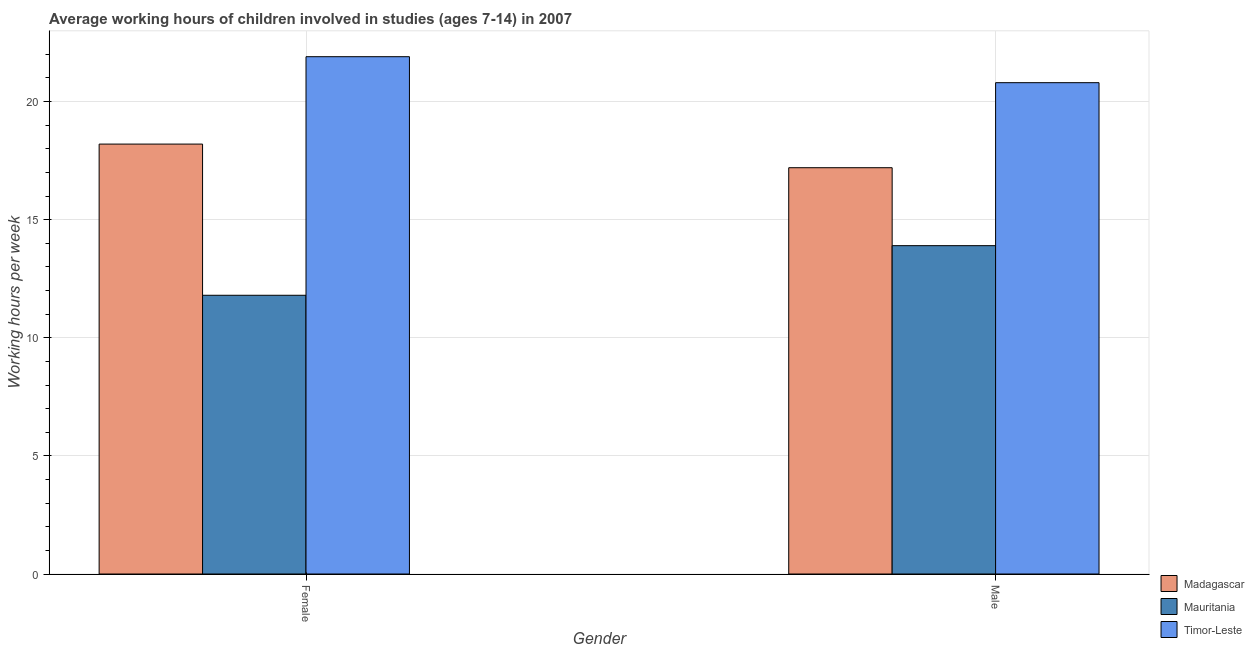How many different coloured bars are there?
Provide a short and direct response. 3. How many groups of bars are there?
Keep it short and to the point. 2. Are the number of bars on each tick of the X-axis equal?
Ensure brevity in your answer.  Yes. How many bars are there on the 2nd tick from the right?
Your answer should be compact. 3. What is the label of the 2nd group of bars from the left?
Your answer should be very brief. Male. What is the average working hour of female children in Mauritania?
Offer a terse response. 11.8. Across all countries, what is the maximum average working hour of female children?
Offer a very short reply. 21.9. Across all countries, what is the minimum average working hour of female children?
Give a very brief answer. 11.8. In which country was the average working hour of male children maximum?
Offer a very short reply. Timor-Leste. In which country was the average working hour of female children minimum?
Provide a succinct answer. Mauritania. What is the total average working hour of male children in the graph?
Keep it short and to the point. 51.9. What is the difference between the average working hour of male children in Mauritania and that in Madagascar?
Your answer should be compact. -3.3. What is the difference between the average working hour of female children in Madagascar and the average working hour of male children in Timor-Leste?
Your answer should be compact. -2.6. What is the average average working hour of female children per country?
Your answer should be compact. 17.3. What is the difference between the average working hour of female children and average working hour of male children in Timor-Leste?
Make the answer very short. 1.1. In how many countries, is the average working hour of female children greater than 7 hours?
Provide a short and direct response. 3. What is the ratio of the average working hour of female children in Madagascar to that in Mauritania?
Provide a short and direct response. 1.54. Is the average working hour of female children in Mauritania less than that in Madagascar?
Ensure brevity in your answer.  Yes. In how many countries, is the average working hour of female children greater than the average average working hour of female children taken over all countries?
Make the answer very short. 2. What does the 3rd bar from the left in Female represents?
Your answer should be very brief. Timor-Leste. What does the 2nd bar from the right in Female represents?
Provide a succinct answer. Mauritania. Are all the bars in the graph horizontal?
Your response must be concise. No. How many countries are there in the graph?
Ensure brevity in your answer.  3. Does the graph contain grids?
Provide a short and direct response. Yes. Where does the legend appear in the graph?
Your response must be concise. Bottom right. How are the legend labels stacked?
Your response must be concise. Vertical. What is the title of the graph?
Keep it short and to the point. Average working hours of children involved in studies (ages 7-14) in 2007. Does "Greenland" appear as one of the legend labels in the graph?
Offer a terse response. No. What is the label or title of the X-axis?
Offer a terse response. Gender. What is the label or title of the Y-axis?
Provide a succinct answer. Working hours per week. What is the Working hours per week in Madagascar in Female?
Your response must be concise. 18.2. What is the Working hours per week in Mauritania in Female?
Keep it short and to the point. 11.8. What is the Working hours per week of Timor-Leste in Female?
Your response must be concise. 21.9. What is the Working hours per week of Madagascar in Male?
Your response must be concise. 17.2. What is the Working hours per week of Timor-Leste in Male?
Provide a short and direct response. 20.8. Across all Gender, what is the maximum Working hours per week in Timor-Leste?
Provide a succinct answer. 21.9. Across all Gender, what is the minimum Working hours per week in Timor-Leste?
Provide a short and direct response. 20.8. What is the total Working hours per week of Madagascar in the graph?
Give a very brief answer. 35.4. What is the total Working hours per week in Mauritania in the graph?
Ensure brevity in your answer.  25.7. What is the total Working hours per week in Timor-Leste in the graph?
Make the answer very short. 42.7. What is the difference between the Working hours per week of Timor-Leste in Female and that in Male?
Offer a terse response. 1.1. What is the difference between the Working hours per week of Mauritania in Female and the Working hours per week of Timor-Leste in Male?
Your answer should be very brief. -9. What is the average Working hours per week in Madagascar per Gender?
Give a very brief answer. 17.7. What is the average Working hours per week of Mauritania per Gender?
Your answer should be compact. 12.85. What is the average Working hours per week of Timor-Leste per Gender?
Your response must be concise. 21.35. What is the difference between the Working hours per week in Madagascar and Working hours per week in Mauritania in Female?
Provide a succinct answer. 6.4. What is the difference between the Working hours per week of Madagascar and Working hours per week of Timor-Leste in Female?
Ensure brevity in your answer.  -3.7. What is the difference between the Working hours per week of Madagascar and Working hours per week of Timor-Leste in Male?
Your response must be concise. -3.6. What is the difference between the Working hours per week in Mauritania and Working hours per week in Timor-Leste in Male?
Provide a succinct answer. -6.9. What is the ratio of the Working hours per week of Madagascar in Female to that in Male?
Make the answer very short. 1.06. What is the ratio of the Working hours per week in Mauritania in Female to that in Male?
Your response must be concise. 0.85. What is the ratio of the Working hours per week of Timor-Leste in Female to that in Male?
Keep it short and to the point. 1.05. What is the difference between the highest and the second highest Working hours per week of Mauritania?
Provide a short and direct response. 2.1. What is the difference between the highest and the lowest Working hours per week in Madagascar?
Your response must be concise. 1. What is the difference between the highest and the lowest Working hours per week of Timor-Leste?
Keep it short and to the point. 1.1. 